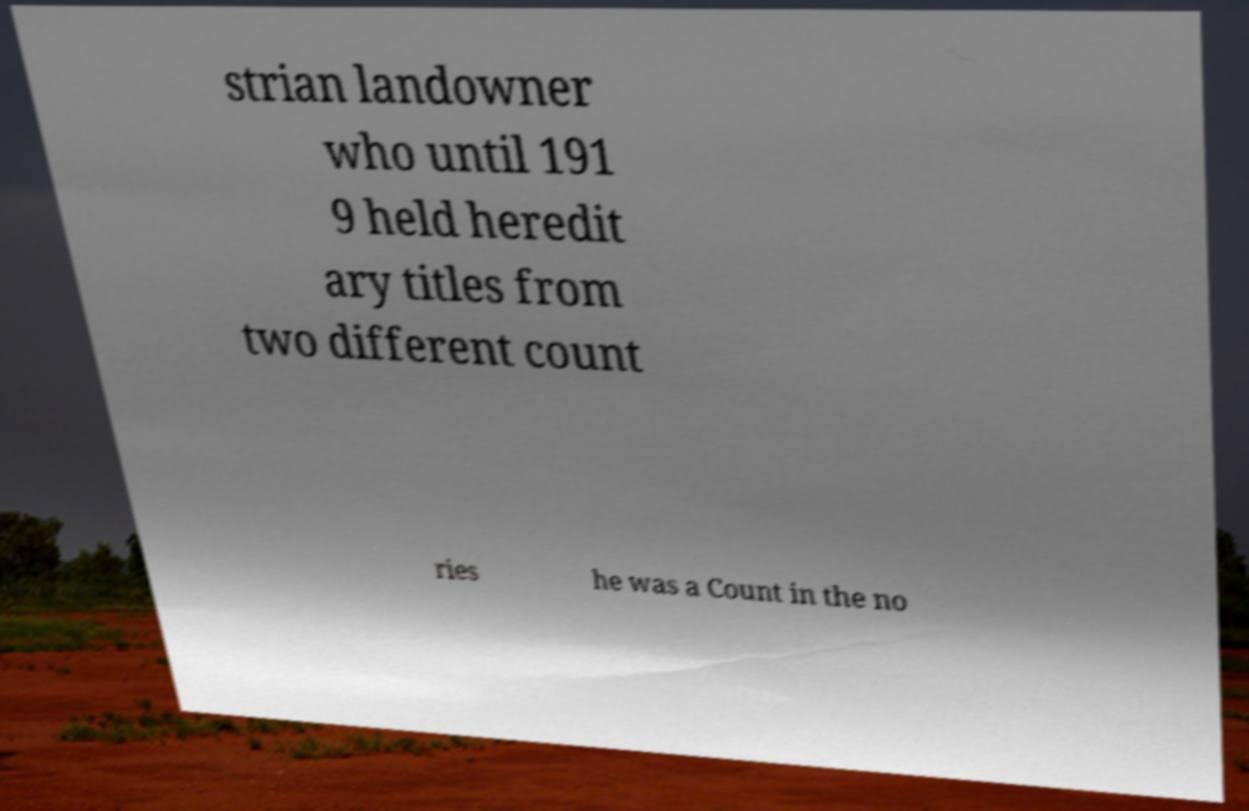I need the written content from this picture converted into text. Can you do that? strian landowner who until 191 9 held heredit ary titles from two different count ries he was a Count in the no 